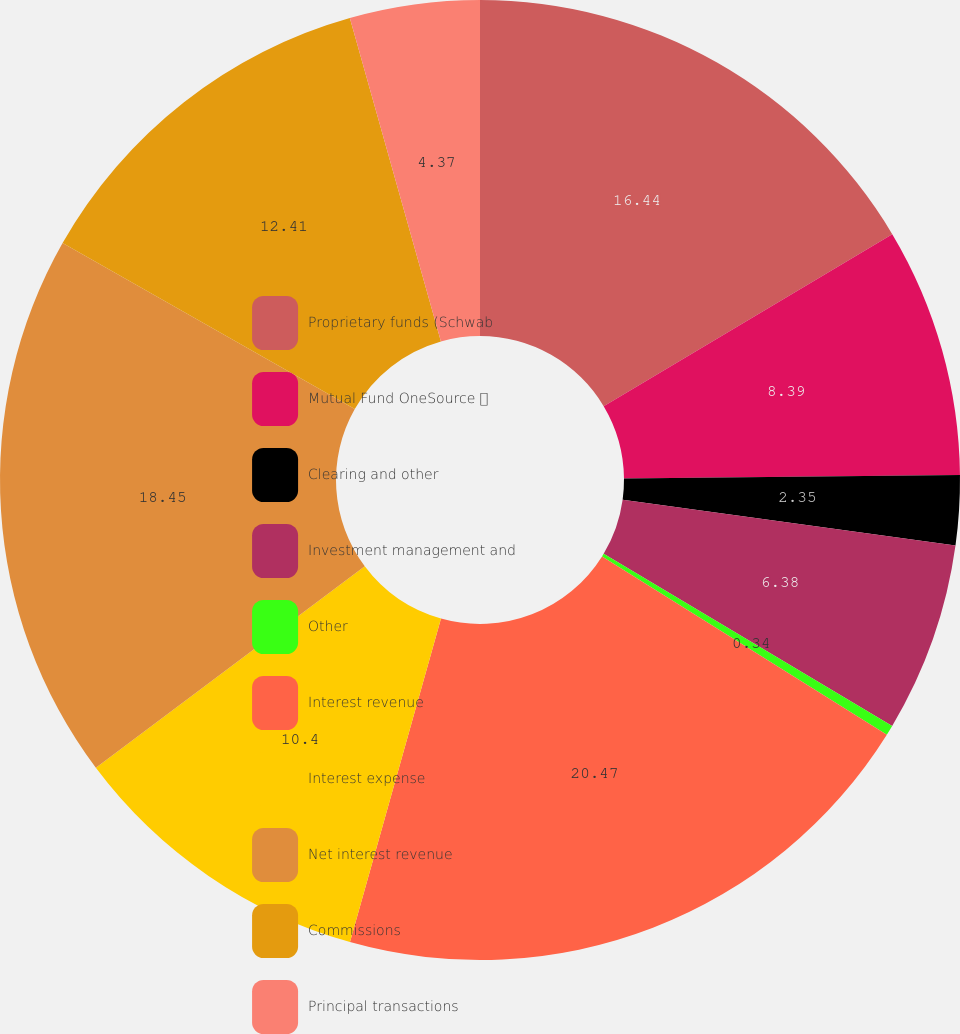Convert chart to OTSL. <chart><loc_0><loc_0><loc_500><loc_500><pie_chart><fcel>Proprietary funds (Schwab<fcel>Mutual Fund OneSource <fcel>Clearing and other<fcel>Investment management and<fcel>Other<fcel>Interest revenue<fcel>Interest expense<fcel>Net interest revenue<fcel>Commissions<fcel>Principal transactions<nl><fcel>16.44%<fcel>8.39%<fcel>2.35%<fcel>6.38%<fcel>0.34%<fcel>20.46%<fcel>10.4%<fcel>18.45%<fcel>12.41%<fcel>4.37%<nl></chart> 